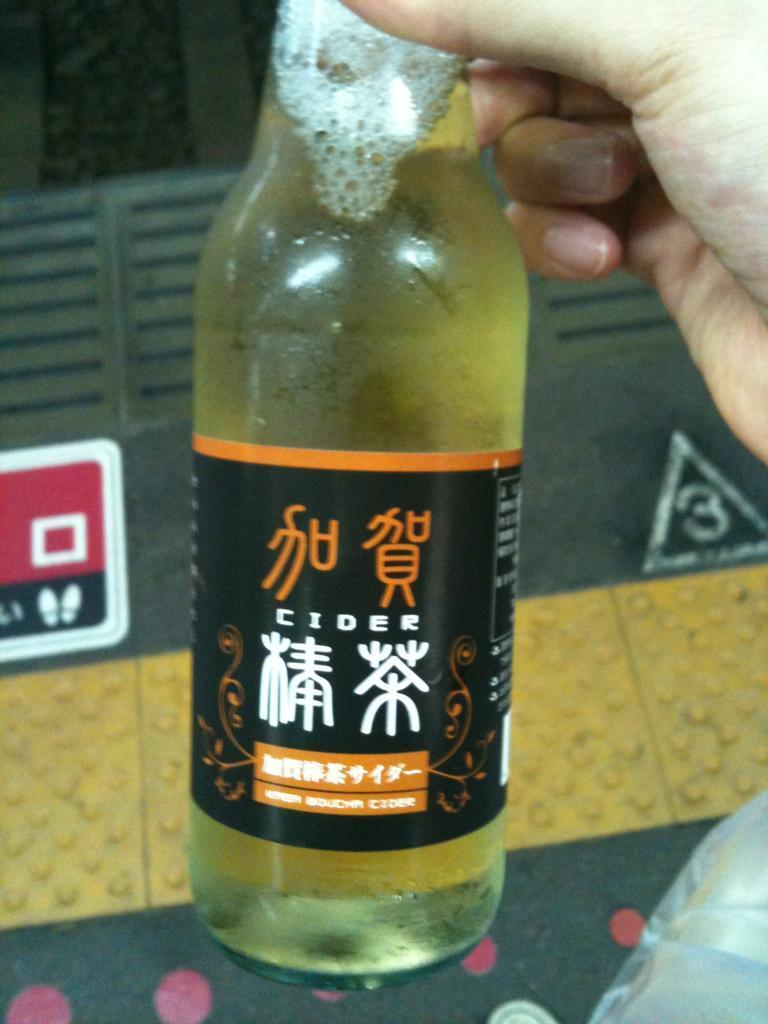<image>
Present a compact description of the photo's key features. A bottle of Chinese Cider can be seen in front of the number 3 in a triangle 